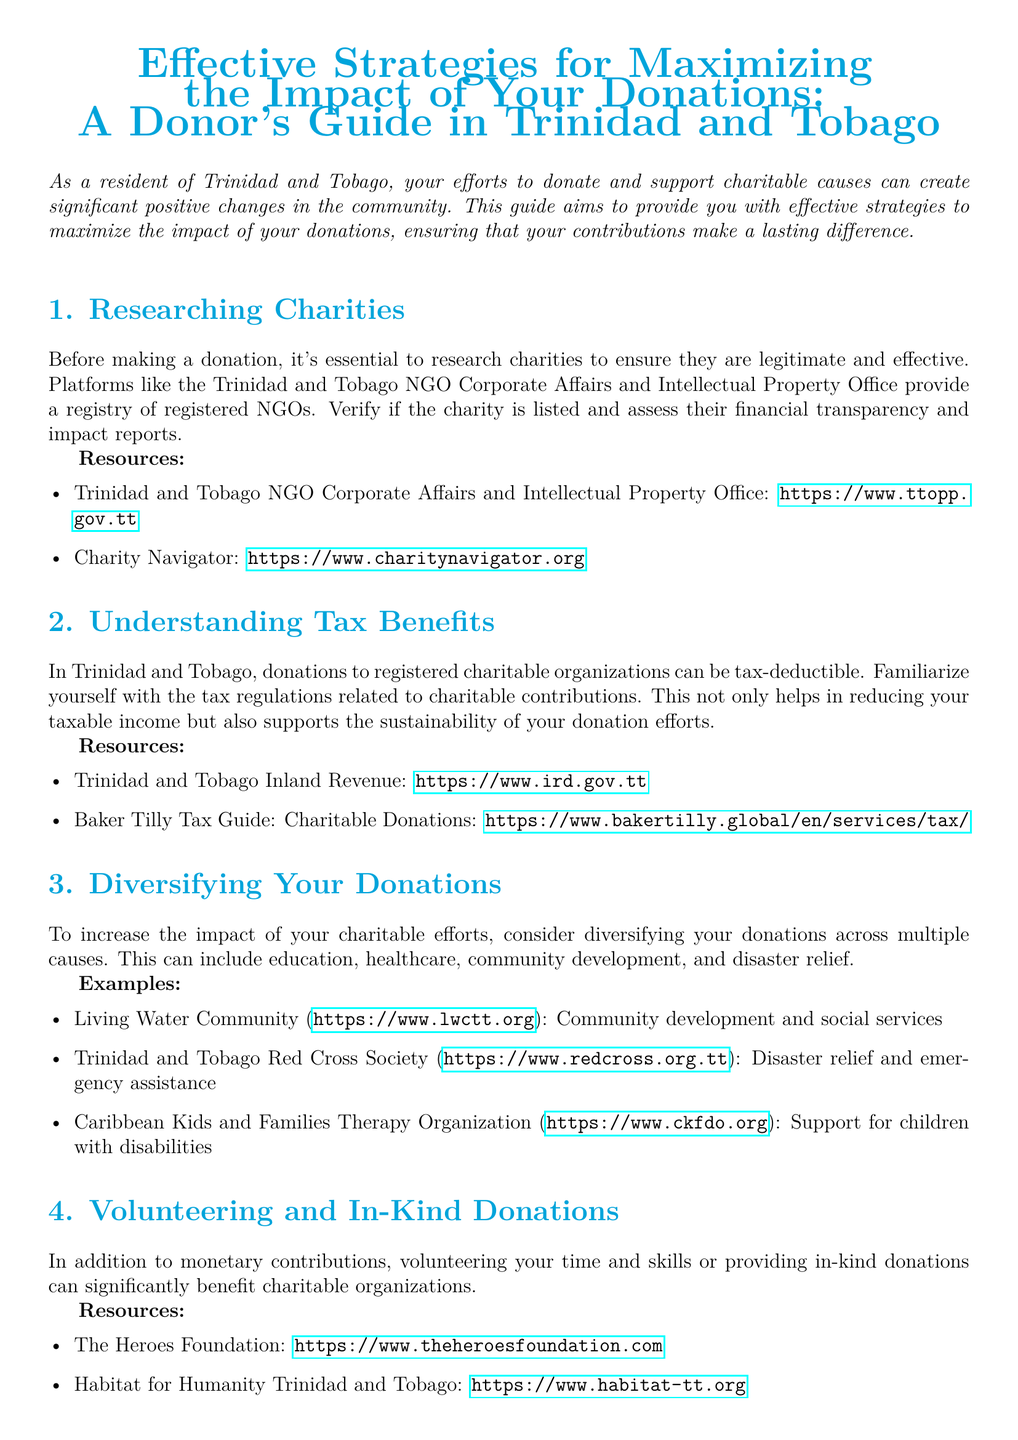What is the title of the whitepaper? The title is provided prominently at the beginning of the document.
Answer: Effective Strategies for Maximizing the Impact of Your Donations: A Donor's Guide in Trinidad and Tobago What is one resource to verify the legitimacy of charities? The document lists specific resources for researching charities.
Answer: Trinidad and Tobago NGO Corporate Affairs and Intellectual Property Office What tax benefit is mentioned in the document? The document discusses tax regulations related to charitable contributions in Trinidad and Tobago.
Answer: Tax-deductible Name a charity focused on community development. The document provides examples of charities and their focus areas.
Answer: Living Water Community Which organization is associated with disaster relief? The document gives specific examples of charities with their causes.
Answer: Trinidad and Tobago Red Cross Society What should donors request from organizations to ensure accountability? The section discusses the importance of monitoring donations.
Answer: Detailed reports What type of donations are encouraged besides monetary contributions? The document emphasizes different forms of contributions.
Answer: In-kind donations How many strategies are outlined in the document? The document is structured with numbered sections detailing strategies.
Answer: Five 